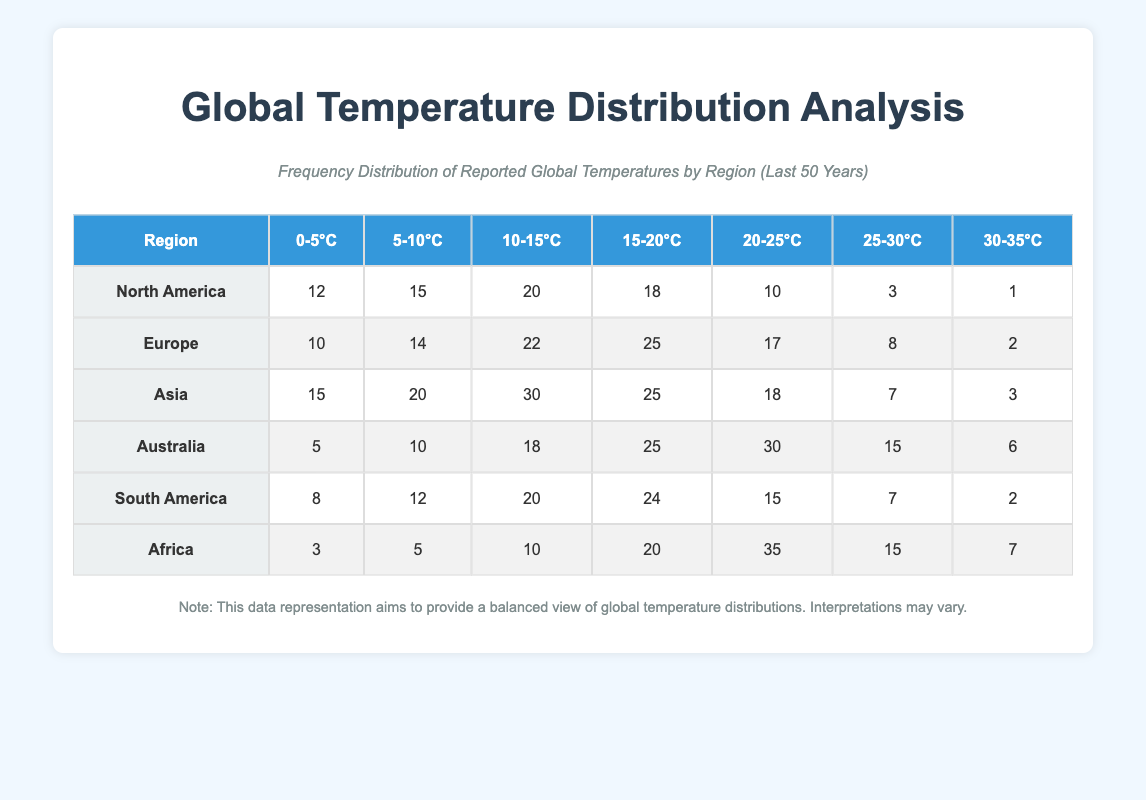What is the highest temperature range reported for Africa? According to the table, Africa has the highest reported temperature range of 20-25°C with a frequency of 35.
Answer: 20-25°C Which region has the lowest count of temperatures in the range of 30-35°C? From the table, North America has the lowest count of temperatures in the range of 30-35°C, with a frequency of 1.
Answer: North America What is the total number of reported temperatures for Australia? To find the total for Australia, we sum the counts across all temperature ranges: 5 + 10 + 18 + 25 + 30 + 15 + 6 = 109.
Answer: 109 How many regions report a temperature of 25-30°C greater than 10? By analyzing the table, Australia (15), Asia (7), and Africa (15) report this; that means only Australia and Africa meet the criteria.
Answer: 2 True or False: Europe has a higher total count than North America. The total for Europe is 10 + 14 + 22 + 25 + 17 + 8 + 2 = 108, while North America totals 12 + 15 + 20 + 18 + 10 + 3 + 1 = 79. Therefore, it's true that Europe has a higher total count.
Answer: True What is the average reported temperature count for the 20-25°C range across all regions? We find the frequency for 20-25°C in each region and then calculate the average: North America (10), Europe (17), Asia (18), Australia (30), South America (15), and Africa (35). Sum: 10 + 17 + 18 + 30 + 15 + 35 = 125. There are 6 regions, so the average is 125/6 = 20.83.
Answer: 20.83 Which temperature range has the highest total frequency across all regions? First, we add the frequencies for each range across all regions: 0-5°C (12 + 10 + 15 + 5 + 8 + 3 = 53), 5-10°C (15 + 14 + 20 + 10 + 12 + 5 = 86), 10-15°C (20 + 22 + 30 + 18 + 20 + 10 = 130), 15-20°C (18 + 25 + 25 + 25 + 24 + 20 = 137), 20-25°C (10 + 17 + 18 + 30 + 15 + 35 = 125), 25-30°C (3 + 8 + 7 + 15 + 7 + 15 = 55), 30-35°C (1 + 2 + 3 + 6 + 2 + 7 = 21). The highest total is for 15-20°C.
Answer: 15-20°C What is the difference in reported temperatures between the highest and the lowest ranges in Asia? Asia reports the highest frequency in the 10-15°C range (30) and the lowest in the 30-35°C range (3). The difference is 30 - 3 = 27.
Answer: 27 